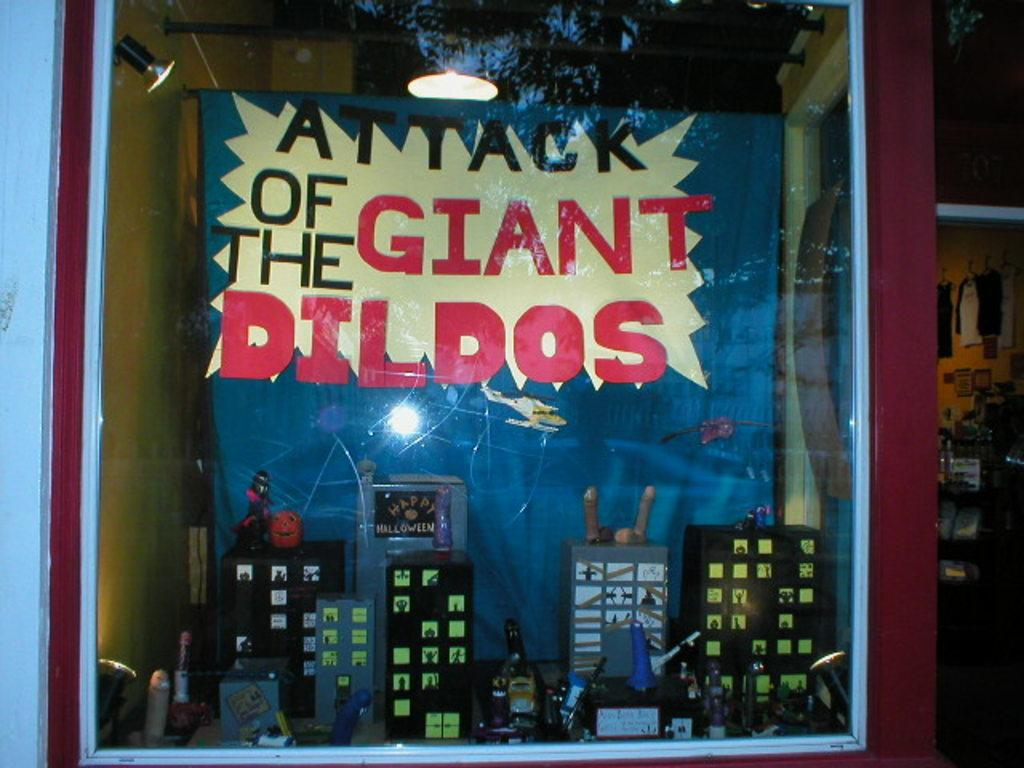<image>
Give a short and clear explanation of the subsequent image. An art piece of city buildings at night. The art work is called attack of the giant dildos. There different size dildos all over the city. 